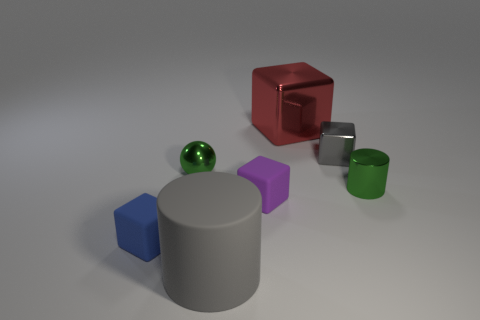Subtract 1 blocks. How many blocks are left? 3 Add 2 red shiny objects. How many objects exist? 9 Subtract all spheres. How many objects are left? 6 Subtract 0 red cylinders. How many objects are left? 7 Subtract all large metal objects. Subtract all tiny purple blocks. How many objects are left? 5 Add 4 green cylinders. How many green cylinders are left? 5 Add 2 small green metal objects. How many small green metal objects exist? 4 